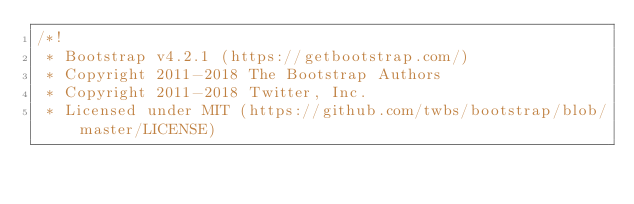Convert code to text. <code><loc_0><loc_0><loc_500><loc_500><_CSS_>/*!
 * Bootstrap v4.2.1 (https://getbootstrap.com/)
 * Copyright 2011-2018 The Bootstrap Authors
 * Copyright 2011-2018 Twitter, Inc.
 * Licensed under MIT (https://github.com/twbs/bootstrap/blob/master/LICENSE)</code> 